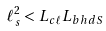<formula> <loc_0><loc_0><loc_500><loc_500>\ell _ { s } ^ { 2 } < L _ { c \ell } L _ { b h d S }</formula> 